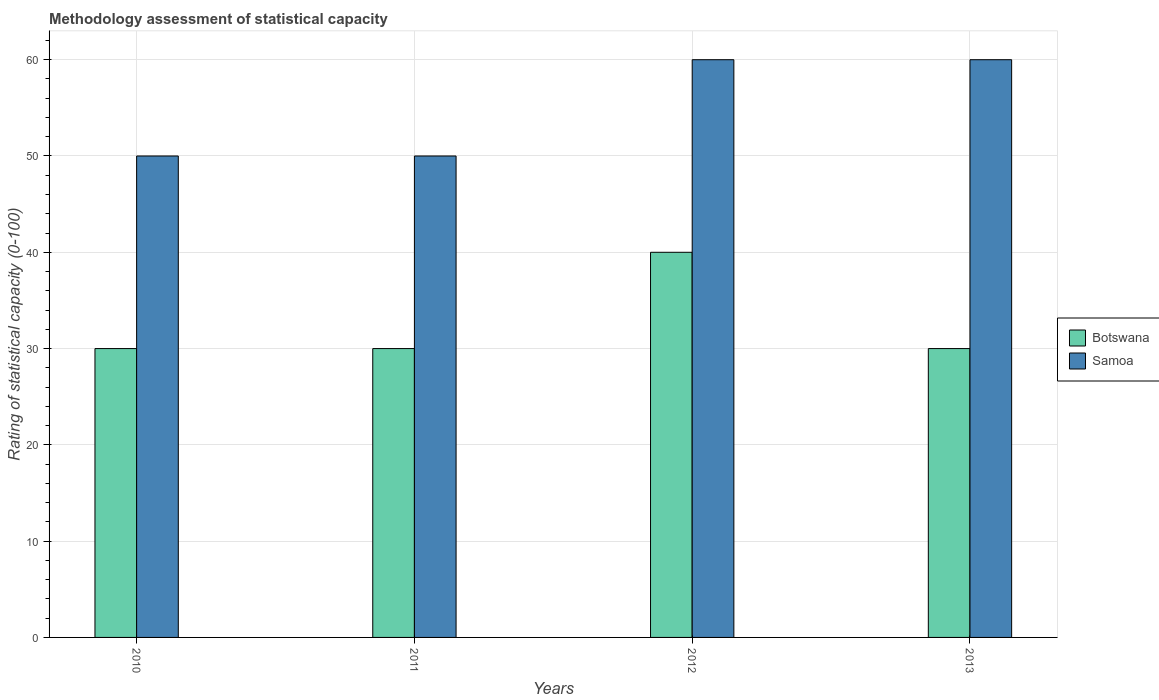How many different coloured bars are there?
Ensure brevity in your answer.  2. Are the number of bars per tick equal to the number of legend labels?
Provide a short and direct response. Yes. Are the number of bars on each tick of the X-axis equal?
Give a very brief answer. Yes. How many bars are there on the 2nd tick from the left?
Your response must be concise. 2. What is the rating of statistical capacity in Botswana in 2010?
Provide a short and direct response. 30. Across all years, what is the minimum rating of statistical capacity in Botswana?
Your response must be concise. 30. In which year was the rating of statistical capacity in Samoa maximum?
Your response must be concise. 2012. What is the total rating of statistical capacity in Samoa in the graph?
Your response must be concise. 220. What is the average rating of statistical capacity in Botswana per year?
Your response must be concise. 32.5. In how many years, is the rating of statistical capacity in Botswana greater than 34?
Provide a short and direct response. 1. What is the ratio of the rating of statistical capacity in Samoa in 2011 to that in 2013?
Offer a terse response. 0.83. Is the difference between the rating of statistical capacity in Samoa in 2010 and 2013 greater than the difference between the rating of statistical capacity in Botswana in 2010 and 2013?
Your answer should be very brief. No. What does the 2nd bar from the left in 2010 represents?
Your answer should be compact. Samoa. What does the 1st bar from the right in 2013 represents?
Keep it short and to the point. Samoa. How many bars are there?
Provide a short and direct response. 8. What is the difference between two consecutive major ticks on the Y-axis?
Offer a very short reply. 10. Where does the legend appear in the graph?
Provide a succinct answer. Center right. What is the title of the graph?
Your response must be concise. Methodology assessment of statistical capacity. Does "Estonia" appear as one of the legend labels in the graph?
Your answer should be compact. No. What is the label or title of the X-axis?
Your response must be concise. Years. What is the label or title of the Y-axis?
Ensure brevity in your answer.  Rating of statistical capacity (0-100). What is the Rating of statistical capacity (0-100) in Botswana in 2012?
Your answer should be very brief. 40. Across all years, what is the maximum Rating of statistical capacity (0-100) in Samoa?
Provide a short and direct response. 60. Across all years, what is the minimum Rating of statistical capacity (0-100) of Botswana?
Keep it short and to the point. 30. What is the total Rating of statistical capacity (0-100) of Botswana in the graph?
Provide a short and direct response. 130. What is the total Rating of statistical capacity (0-100) in Samoa in the graph?
Your answer should be very brief. 220. What is the difference between the Rating of statistical capacity (0-100) of Samoa in 2010 and that in 2011?
Provide a short and direct response. 0. What is the difference between the Rating of statistical capacity (0-100) in Botswana in 2010 and that in 2012?
Make the answer very short. -10. What is the difference between the Rating of statistical capacity (0-100) in Samoa in 2010 and that in 2012?
Give a very brief answer. -10. What is the difference between the Rating of statistical capacity (0-100) of Botswana in 2010 and that in 2013?
Provide a succinct answer. 0. What is the difference between the Rating of statistical capacity (0-100) of Botswana in 2011 and that in 2012?
Your answer should be very brief. -10. What is the difference between the Rating of statistical capacity (0-100) in Botswana in 2011 and that in 2013?
Ensure brevity in your answer.  0. What is the difference between the Rating of statistical capacity (0-100) in Botswana in 2010 and the Rating of statistical capacity (0-100) in Samoa in 2011?
Provide a succinct answer. -20. What is the difference between the Rating of statistical capacity (0-100) of Botswana in 2010 and the Rating of statistical capacity (0-100) of Samoa in 2012?
Make the answer very short. -30. What is the difference between the Rating of statistical capacity (0-100) of Botswana in 2010 and the Rating of statistical capacity (0-100) of Samoa in 2013?
Provide a short and direct response. -30. What is the average Rating of statistical capacity (0-100) in Botswana per year?
Keep it short and to the point. 32.5. In the year 2012, what is the difference between the Rating of statistical capacity (0-100) in Botswana and Rating of statistical capacity (0-100) in Samoa?
Give a very brief answer. -20. In the year 2013, what is the difference between the Rating of statistical capacity (0-100) in Botswana and Rating of statistical capacity (0-100) in Samoa?
Make the answer very short. -30. What is the ratio of the Rating of statistical capacity (0-100) of Botswana in 2010 to that in 2011?
Offer a terse response. 1. What is the ratio of the Rating of statistical capacity (0-100) in Samoa in 2010 to that in 2011?
Your answer should be very brief. 1. What is the ratio of the Rating of statistical capacity (0-100) in Samoa in 2010 to that in 2012?
Your answer should be compact. 0.83. What is the ratio of the Rating of statistical capacity (0-100) of Botswana in 2010 to that in 2013?
Offer a terse response. 1. What is the ratio of the Rating of statistical capacity (0-100) in Samoa in 2011 to that in 2012?
Offer a terse response. 0.83. What is the ratio of the Rating of statistical capacity (0-100) of Botswana in 2011 to that in 2013?
Your answer should be compact. 1. What is the ratio of the Rating of statistical capacity (0-100) in Samoa in 2011 to that in 2013?
Offer a very short reply. 0.83. What is the difference between the highest and the second highest Rating of statistical capacity (0-100) in Samoa?
Provide a short and direct response. 0. 